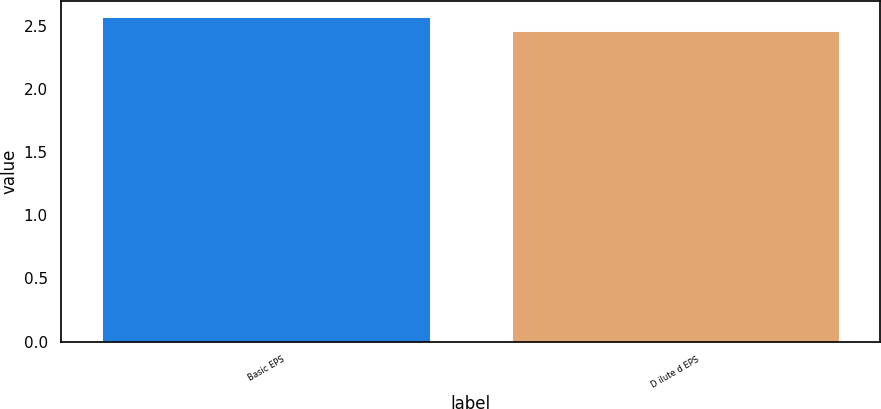<chart> <loc_0><loc_0><loc_500><loc_500><bar_chart><fcel>Basic EPS<fcel>D ilute d EPS<nl><fcel>2.57<fcel>2.46<nl></chart> 